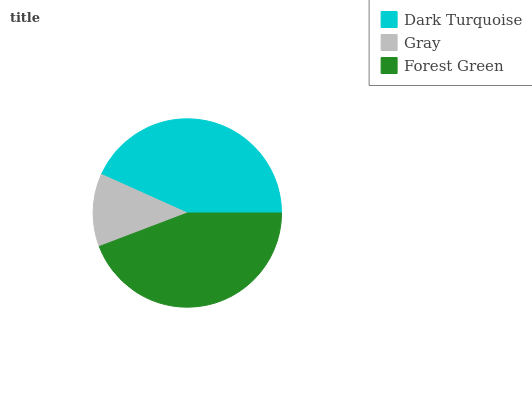Is Gray the minimum?
Answer yes or no. Yes. Is Forest Green the maximum?
Answer yes or no. Yes. Is Forest Green the minimum?
Answer yes or no. No. Is Gray the maximum?
Answer yes or no. No. Is Forest Green greater than Gray?
Answer yes or no. Yes. Is Gray less than Forest Green?
Answer yes or no. Yes. Is Gray greater than Forest Green?
Answer yes or no. No. Is Forest Green less than Gray?
Answer yes or no. No. Is Dark Turquoise the high median?
Answer yes or no. Yes. Is Dark Turquoise the low median?
Answer yes or no. Yes. Is Forest Green the high median?
Answer yes or no. No. Is Forest Green the low median?
Answer yes or no. No. 